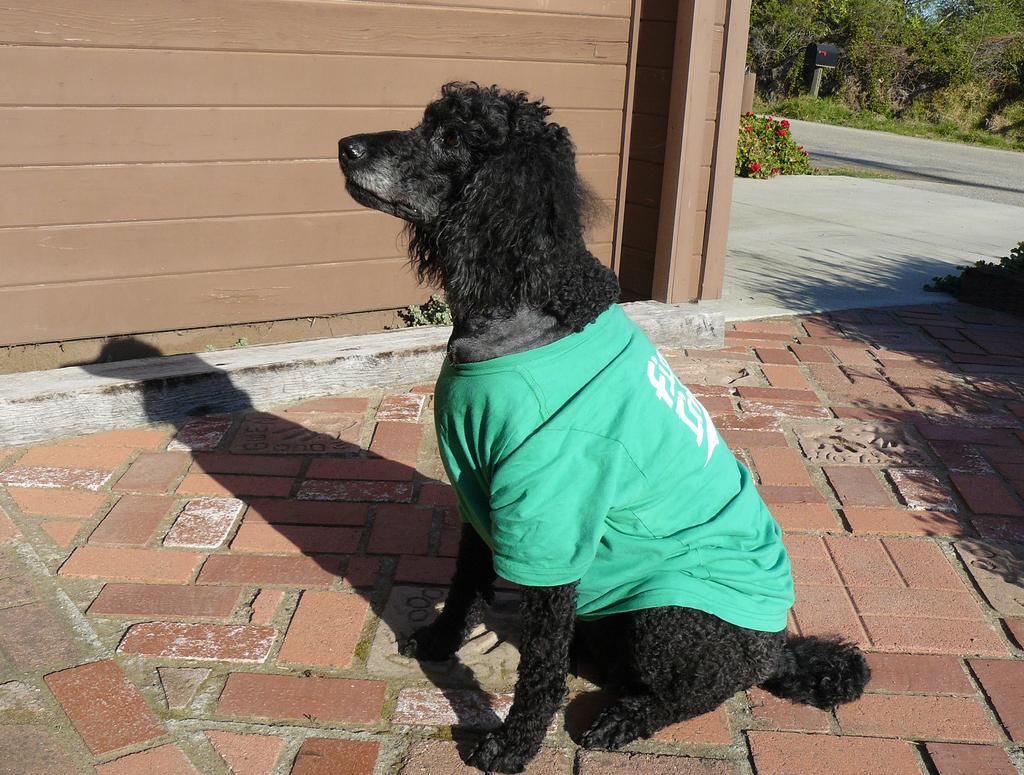Describe this image in one or two sentences. This picture describe about the Black Dog sitting on the cobbler stones wearing a green color t-shirt. Behind we can see a wooden panel wall. In the background you can see some trees and a road. 